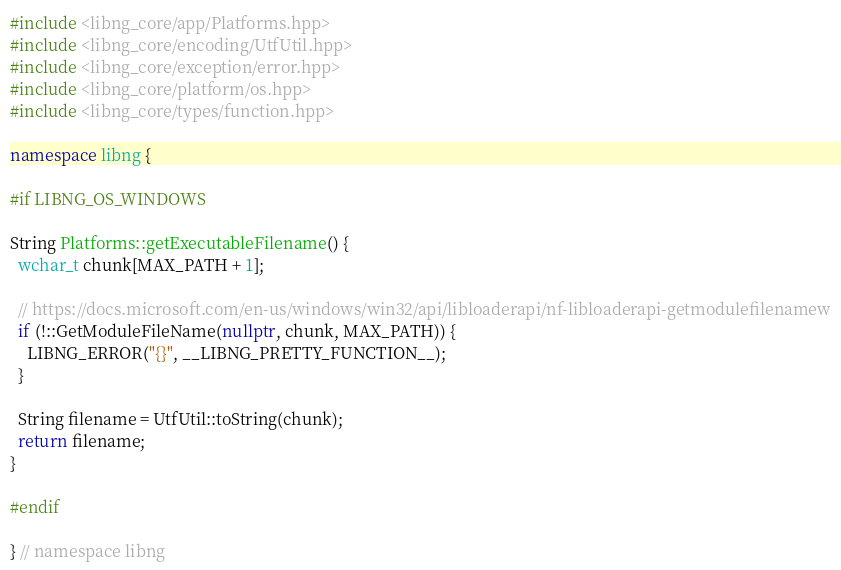Convert code to text. <code><loc_0><loc_0><loc_500><loc_500><_C++_>#include <libng_core/app/Platforms.hpp>
#include <libng_core/encoding/UtfUtil.hpp>
#include <libng_core/exception/error.hpp>
#include <libng_core/platform/os.hpp>
#include <libng_core/types/function.hpp>

namespace libng {

#if LIBNG_OS_WINDOWS

String Platforms::getExecutableFilename() {
  wchar_t chunk[MAX_PATH + 1];

  // https://docs.microsoft.com/en-us/windows/win32/api/libloaderapi/nf-libloaderapi-getmodulefilenamew
  if (!::GetModuleFileName(nullptr, chunk, MAX_PATH)) {
    LIBNG_ERROR("{}", __LIBNG_PRETTY_FUNCTION__);
  }

  String filename = UtfUtil::toString(chunk);
  return filename;
}

#endif

} // namespace libng</code> 